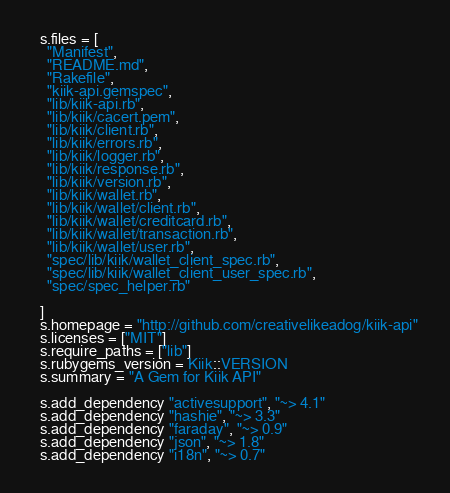Convert code to text. <code><loc_0><loc_0><loc_500><loc_500><_Ruby_>
  s.files = [
    "Manifest",
    "README.md",
    "Rakefile",
    "kiik-api.gemspec",
    "lib/kiik-api.rb",
    "lib/kiik/cacert.pem",
    "lib/kiik/client.rb",
    "lib/kiik/errors.rb",
    "lib/kiik/logger.rb",
    "lib/kiik/response.rb",
    "lib/kiik/version.rb",
    "lib/kiik/wallet.rb",
    "lib/kiik/wallet/client.rb",
    "lib/kiik/wallet/creditcard.rb",
    "lib/kiik/wallet/transaction.rb",
    "lib/kiik/wallet/user.rb",
    "spec/lib/kiik/wallet_client_spec.rb",
    "spec/lib/kiik/wallet_client_user_spec.rb",
    "spec/spec_helper.rb"

  ]
  s.homepage = "http://github.com/creativelikeadog/kiik-api"
  s.licenses = ["MIT"]
  s.require_paths = ["lib"]
  s.rubygems_version = Kiik::VERSION
  s.summary = "A Gem for Kiik API"

  s.add_dependency "activesupport", "~> 4.1"
  s.add_dependency "hashie", "~> 3.3"
  s.add_dependency "faraday", "~> 0.9"
  s.add_dependency "json", "~> 1.8"
  s.add_dependency "i18n", "~> 0.7"</code> 